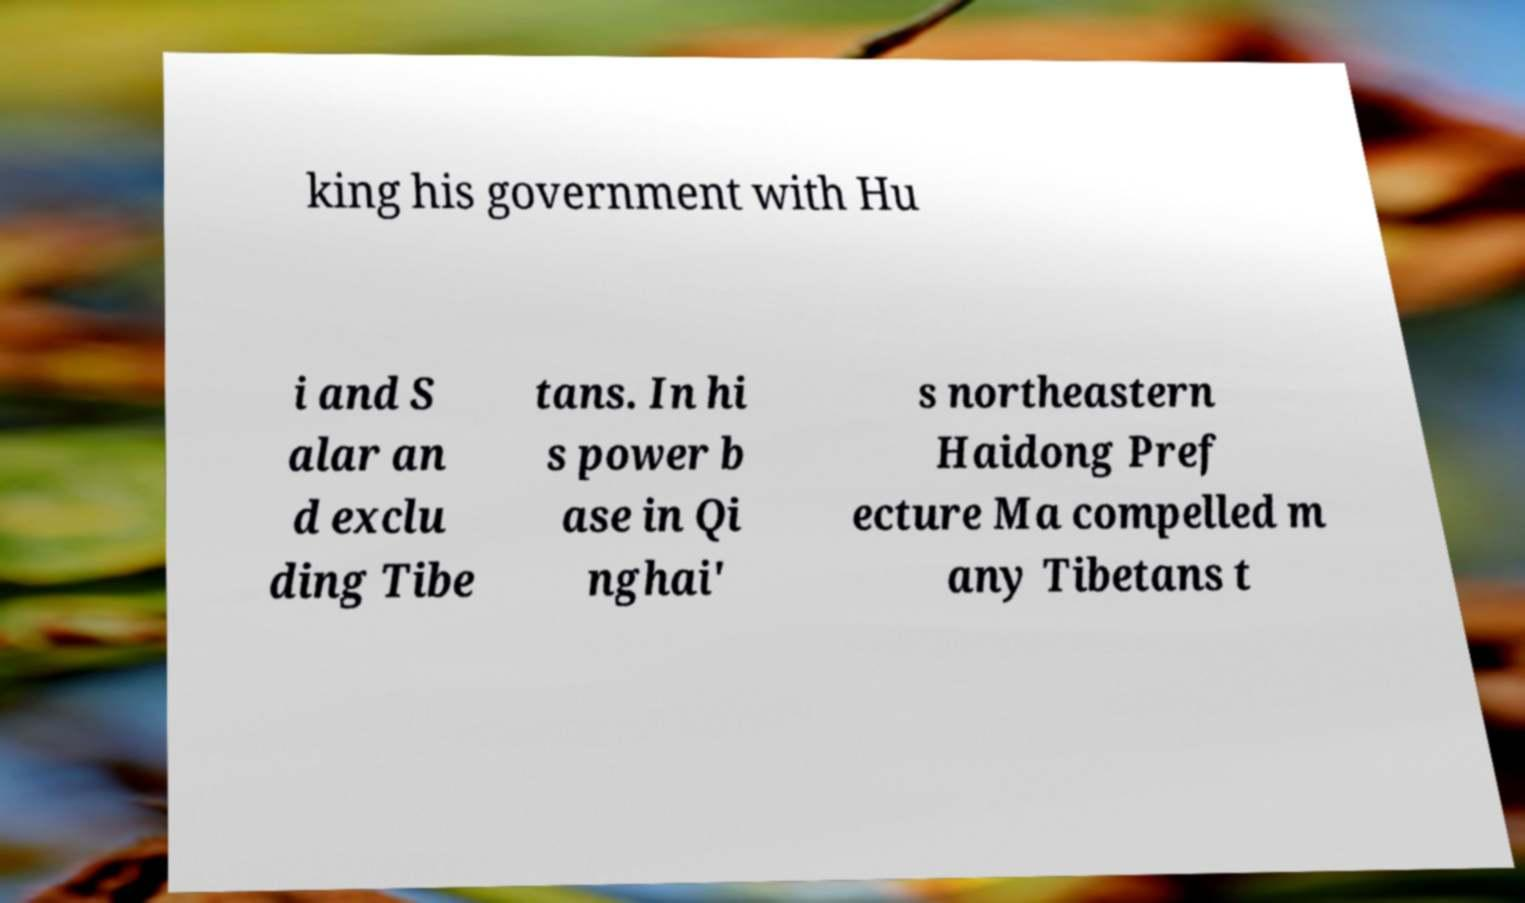Can you read and provide the text displayed in the image?This photo seems to have some interesting text. Can you extract and type it out for me? king his government with Hu i and S alar an d exclu ding Tibe tans. In hi s power b ase in Qi nghai' s northeastern Haidong Pref ecture Ma compelled m any Tibetans t 